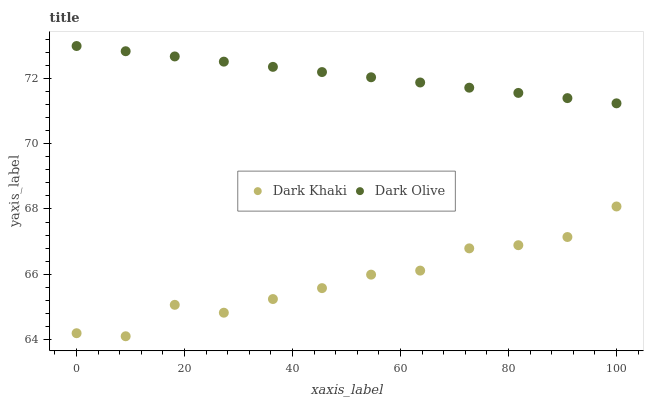Does Dark Khaki have the minimum area under the curve?
Answer yes or no. Yes. Does Dark Olive have the maximum area under the curve?
Answer yes or no. Yes. Does Dark Olive have the minimum area under the curve?
Answer yes or no. No. Is Dark Olive the smoothest?
Answer yes or no. Yes. Is Dark Khaki the roughest?
Answer yes or no. Yes. Is Dark Olive the roughest?
Answer yes or no. No. Does Dark Khaki have the lowest value?
Answer yes or no. Yes. Does Dark Olive have the lowest value?
Answer yes or no. No. Does Dark Olive have the highest value?
Answer yes or no. Yes. Is Dark Khaki less than Dark Olive?
Answer yes or no. Yes. Is Dark Olive greater than Dark Khaki?
Answer yes or no. Yes. Does Dark Khaki intersect Dark Olive?
Answer yes or no. No. 